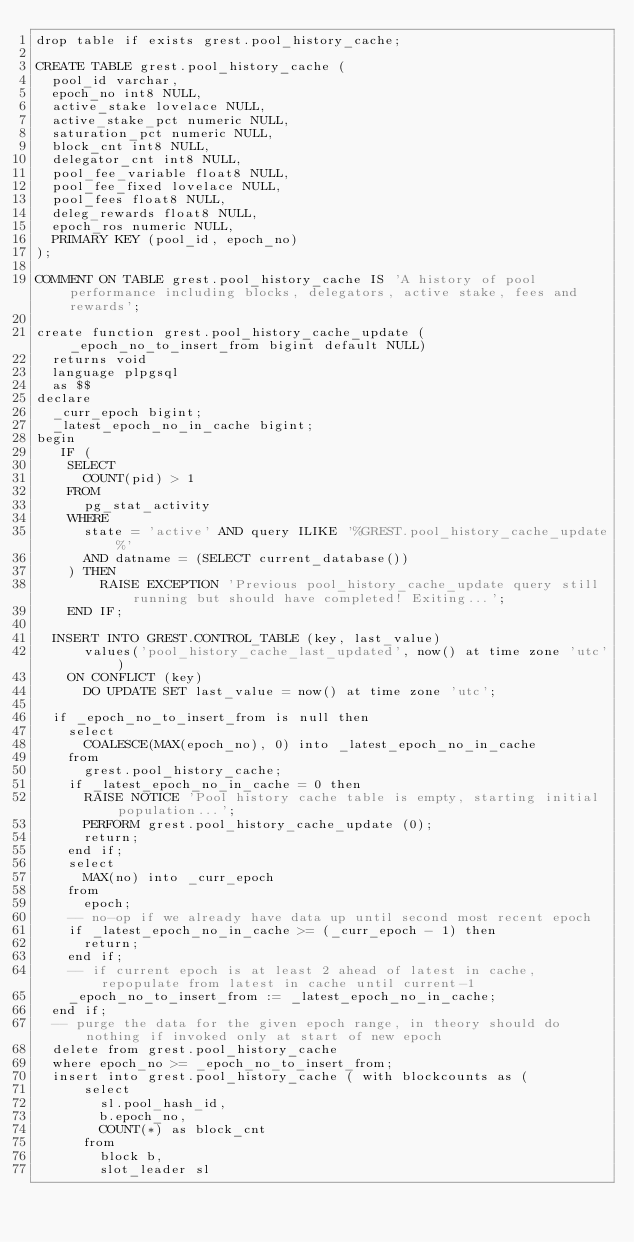<code> <loc_0><loc_0><loc_500><loc_500><_SQL_>drop table if exists grest.pool_history_cache;

CREATE TABLE grest.pool_history_cache (
  pool_id varchar,
  epoch_no int8 NULL,
  active_stake lovelace NULL,
  active_stake_pct numeric NULL,
  saturation_pct numeric NULL,
  block_cnt int8 NULL,
  delegator_cnt int8 NULL,
  pool_fee_variable float8 NULL,
  pool_fee_fixed lovelace NULL,
  pool_fees float8 NULL,
  deleg_rewards float8 NULL,
  epoch_ros numeric NULL,
  PRIMARY KEY (pool_id, epoch_no)
);

COMMENT ON TABLE grest.pool_history_cache IS 'A history of pool performance including blocks, delegators, active stake, fees and rewards';

create function grest.pool_history_cache_update (_epoch_no_to_insert_from bigint default NULL)
  returns void
  language plpgsql
  as $$
declare
  _curr_epoch bigint;
  _latest_epoch_no_in_cache bigint;
begin
   IF (
    SELECT
      COUNT(pid) > 1
    FROM
      pg_stat_activity
    WHERE
      state = 'active' AND query ILIKE '%GREST.pool_history_cache_update%'
      AND datname = (SELECT current_database())
    ) THEN
        RAISE EXCEPTION 'Previous pool_history_cache_update query still running but should have completed! Exiting...';
    END IF;

  INSERT INTO GREST.CONTROL_TABLE (key, last_value)
      values('pool_history_cache_last_updated', now() at time zone 'utc')
    ON CONFLICT (key)
      DO UPDATE SET last_value = now() at time zone 'utc';

  if _epoch_no_to_insert_from is null then
    select
      COALESCE(MAX(epoch_no), 0) into _latest_epoch_no_in_cache
    from
      grest.pool_history_cache;
    if _latest_epoch_no_in_cache = 0 then
      RAISE NOTICE 'Pool history cache table is empty, starting initial population...';
      PERFORM grest.pool_history_cache_update (0);
      return;
    end if;
    select
      MAX(no) into _curr_epoch
    from
      epoch;
    -- no-op if we already have data up until second most recent epoch
    if _latest_epoch_no_in_cache >= (_curr_epoch - 1) then
      return;
    end if;
    -- if current epoch is at least 2 ahead of latest in cache, repopulate from latest in cache until current-1
    _epoch_no_to_insert_from := _latest_epoch_no_in_cache;
  end if;
  -- purge the data for the given epoch range, in theory should do nothing if invoked only at start of new epoch
  delete from grest.pool_history_cache
  where epoch_no >= _epoch_no_to_insert_from;
  insert into grest.pool_history_cache ( with blockcounts as (
      select
        sl.pool_hash_id,
        b.epoch_no,
        COUNT(*) as block_cnt
      from
        block b,
        slot_leader sl</code> 